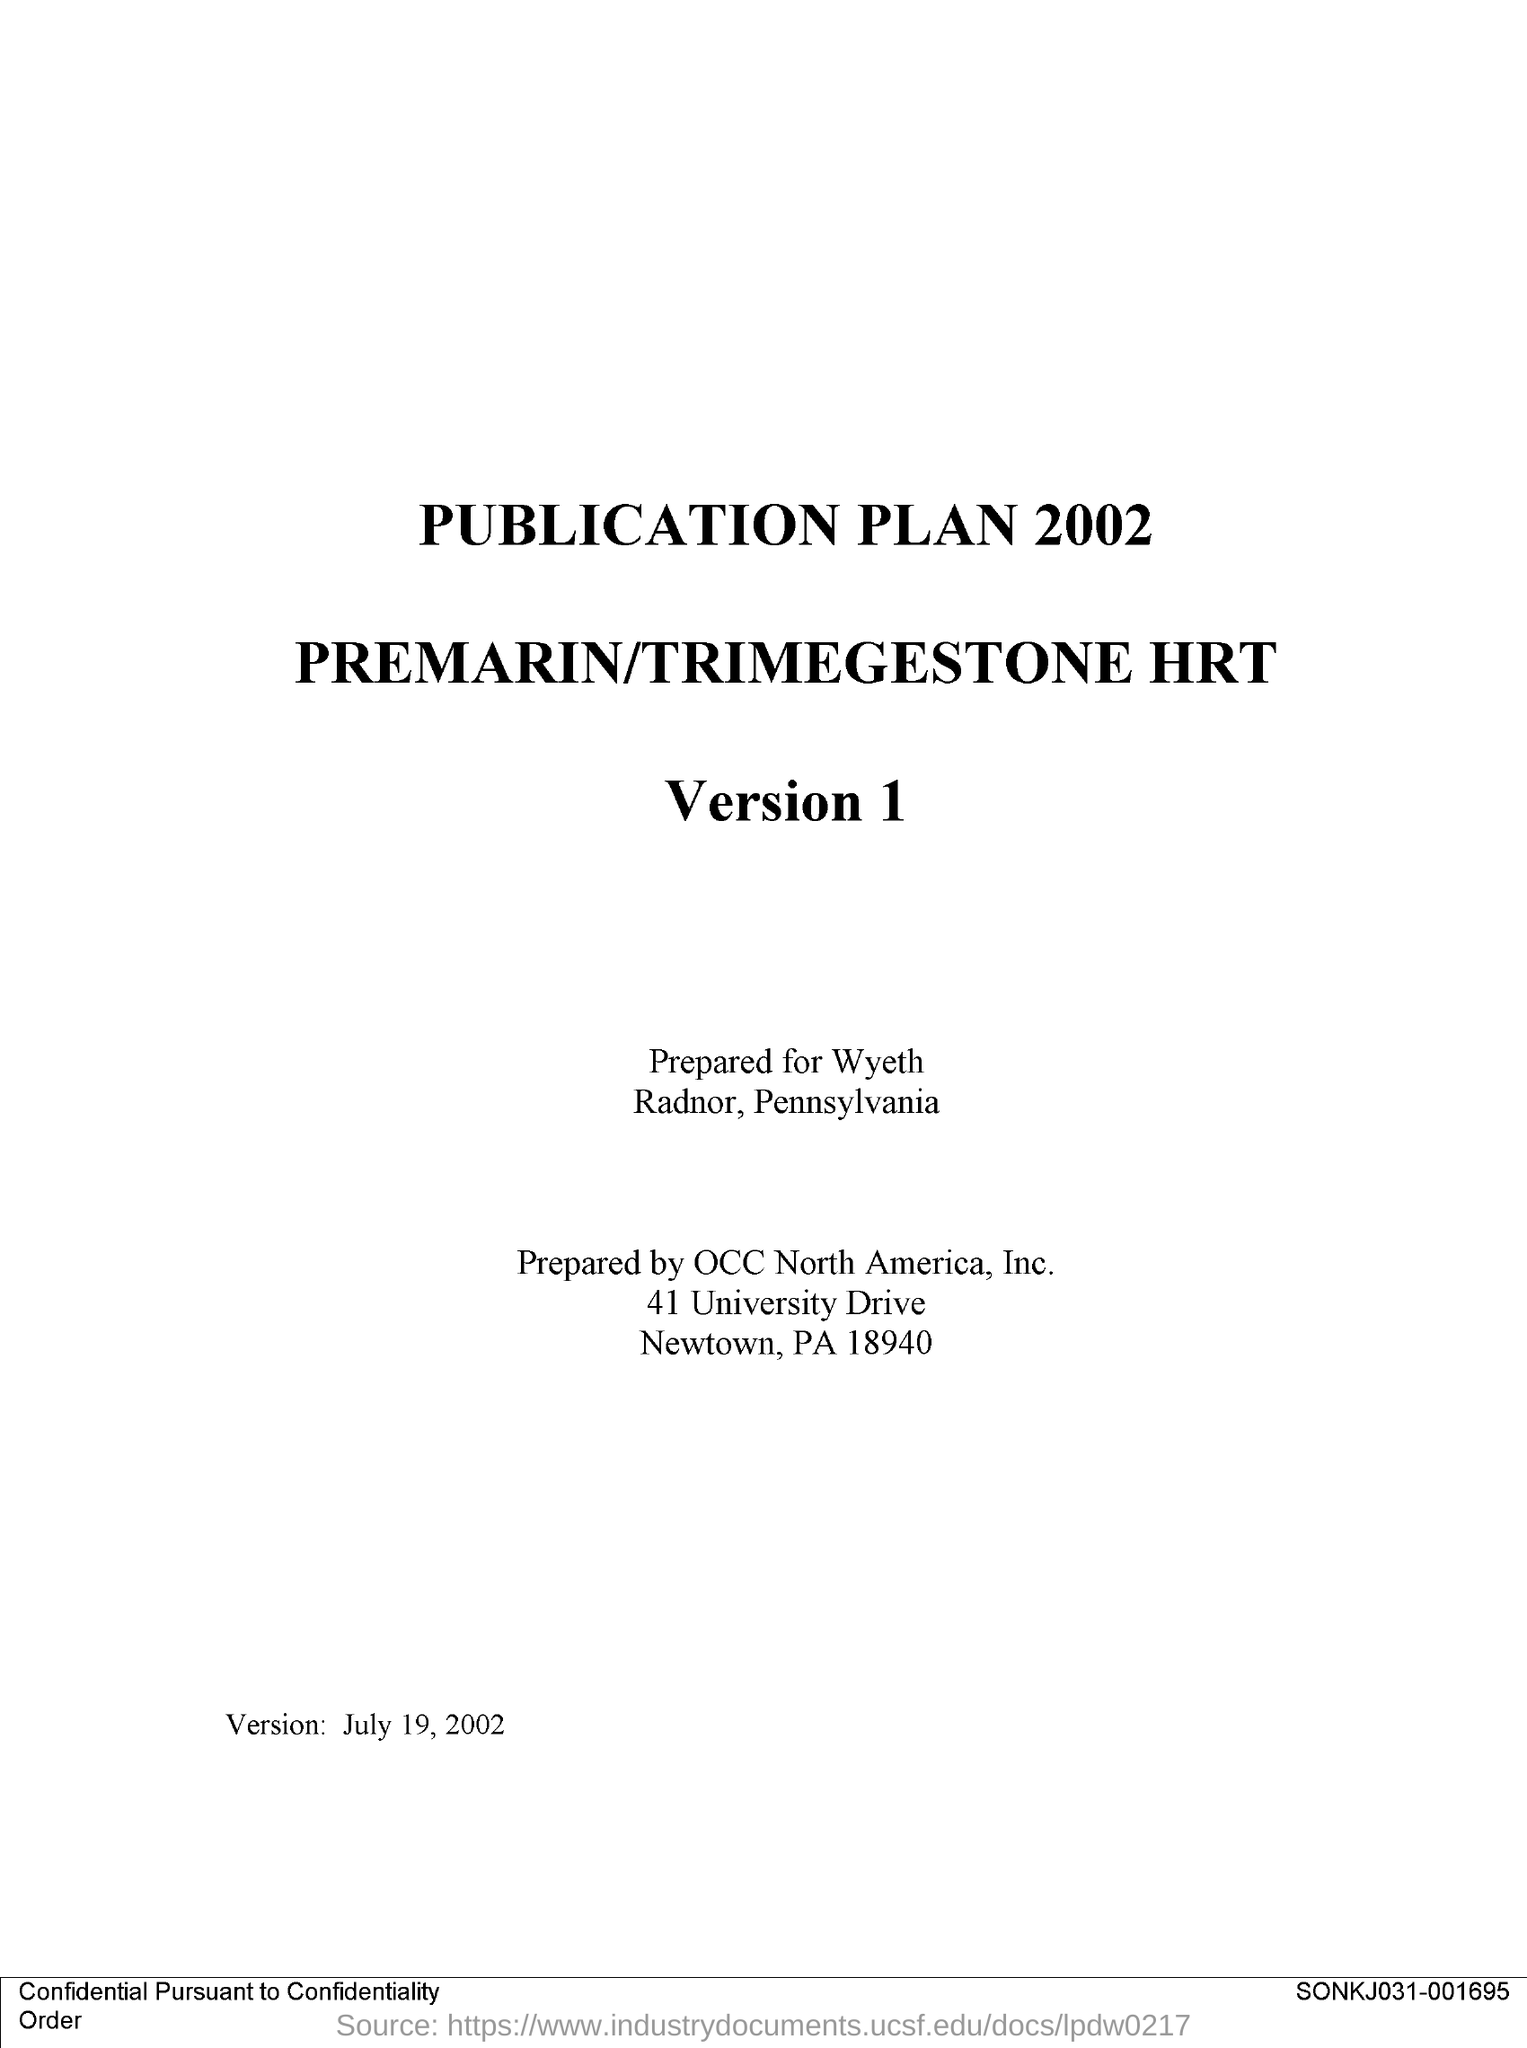What is the first title in the document?
Your answer should be very brief. Publication plan 2002. 